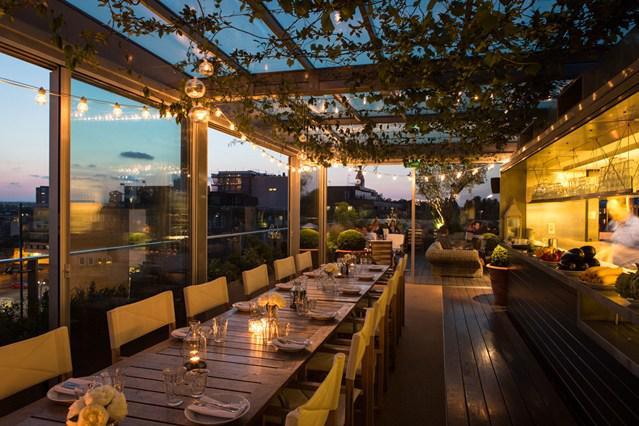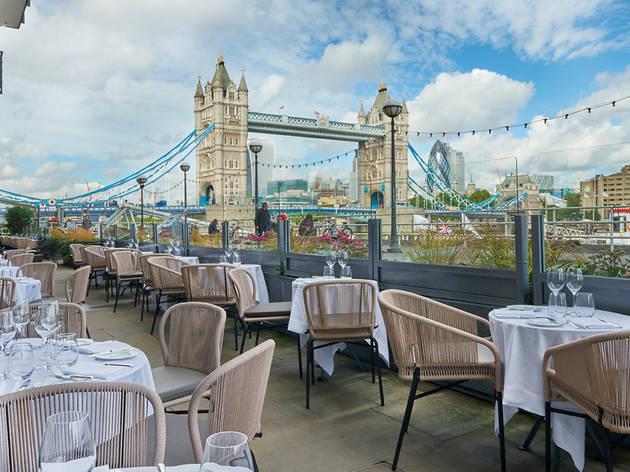The first image is the image on the left, the second image is the image on the right. Analyze the images presented: Is the assertion "One image shows indoor seating at a restaurant and the other shows outdoor seating." valid? Answer yes or no. Yes. 